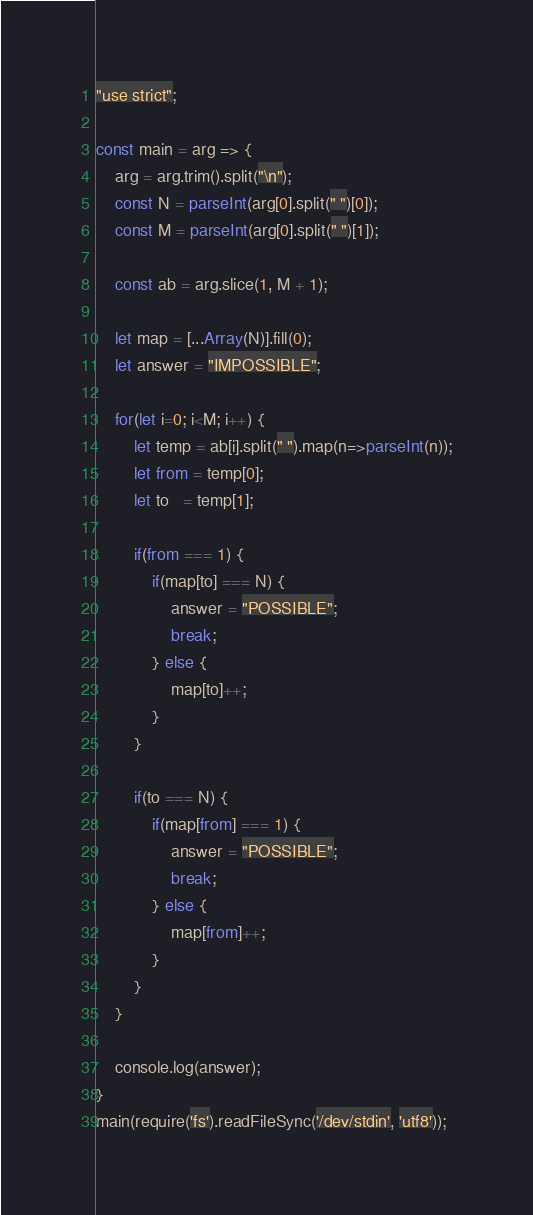Convert code to text. <code><loc_0><loc_0><loc_500><loc_500><_JavaScript_>"use strict";
    
const main = arg => {
    arg = arg.trim().split("\n");
    const N = parseInt(arg[0].split(" ")[0]);
    const M = parseInt(arg[0].split(" ")[1]);
    
    const ab = arg.slice(1, M + 1);
    
    let map = [...Array(N)].fill(0);
    let answer = "IMPOSSIBLE";
    
    for(let i=0; i<M; i++) {
        let temp = ab[i].split(" ").map(n=>parseInt(n));
        let from = temp[0];
        let to   = temp[1];
        
        if(from === 1) {
            if(map[to] === N) {
                answer = "POSSIBLE";
                break;
            } else {
                map[to]++;
            }
        }
        
        if(to === N) {
            if(map[from] === 1) {
                answer = "POSSIBLE";
                break;
            } else {
                map[from]++;
            }
        }
    }
        
    console.log(answer);
}
main(require('fs').readFileSync('/dev/stdin', 'utf8'));
</code> 